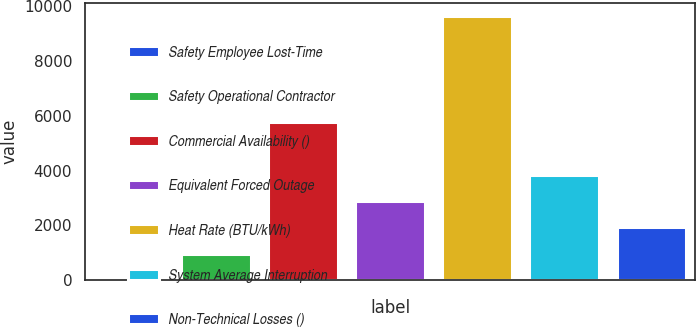Convert chart to OTSL. <chart><loc_0><loc_0><loc_500><loc_500><bar_chart><fcel>Safety Employee Lost-Time<fcel>Safety Operational Contractor<fcel>Commercial Availability ()<fcel>Equivalent Forced Outage<fcel>Heat Rate (BTU/kWh)<fcel>System Average Interruption<fcel>Non-Technical Losses ()<nl><fcel>0.1<fcel>963.89<fcel>5782.84<fcel>2891.47<fcel>9638<fcel>3855.26<fcel>1927.68<nl></chart> 